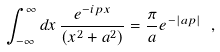<formula> <loc_0><loc_0><loc_500><loc_500>\int ^ { \infty } _ { - \infty } d x \, \frac { e ^ { - i p x } } { ( x ^ { 2 } + a ^ { 2 } ) } = \frac { \pi } { a } e ^ { - | a p | } \ ,</formula> 